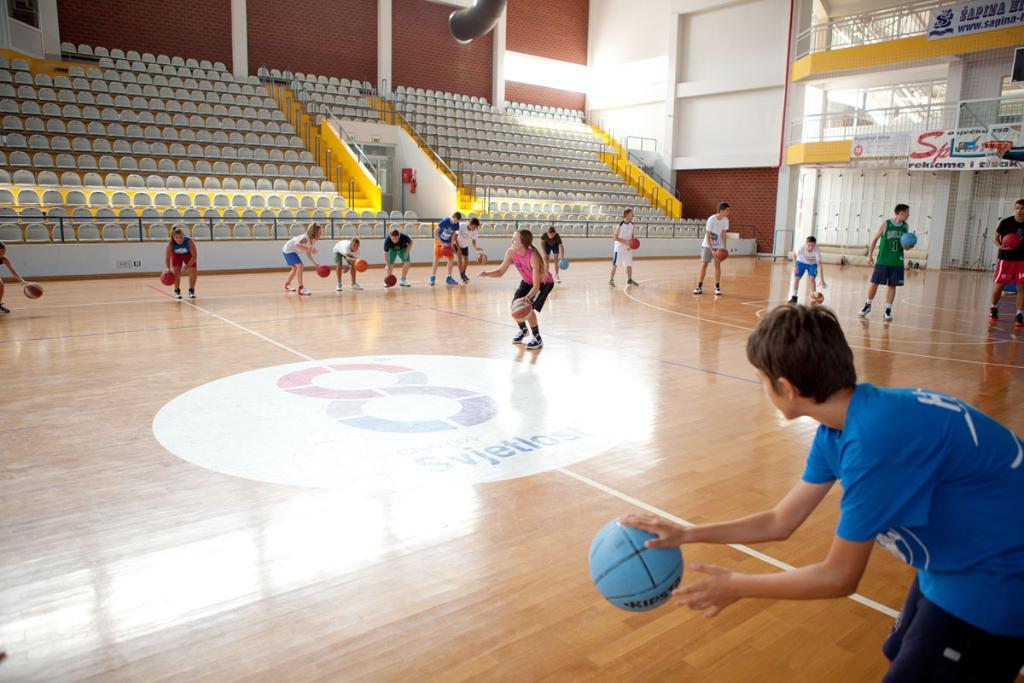<image>
Provide a brief description of the given image. the logo on the center of the gym floor is a figure 8 